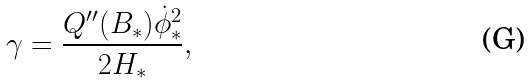Convert formula to latex. <formula><loc_0><loc_0><loc_500><loc_500>\gamma = \frac { Q ^ { \prime \prime } ( B _ { * } ) \dot { \phi } _ { * } ^ { 2 } } { 2 H _ { * } } ,</formula> 